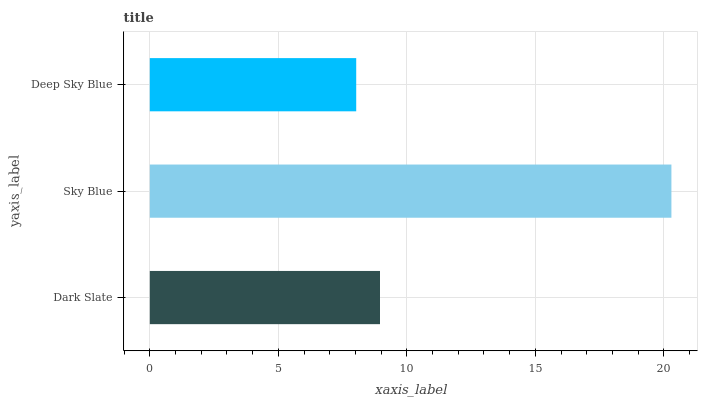Is Deep Sky Blue the minimum?
Answer yes or no. Yes. Is Sky Blue the maximum?
Answer yes or no. Yes. Is Sky Blue the minimum?
Answer yes or no. No. Is Deep Sky Blue the maximum?
Answer yes or no. No. Is Sky Blue greater than Deep Sky Blue?
Answer yes or no. Yes. Is Deep Sky Blue less than Sky Blue?
Answer yes or no. Yes. Is Deep Sky Blue greater than Sky Blue?
Answer yes or no. No. Is Sky Blue less than Deep Sky Blue?
Answer yes or no. No. Is Dark Slate the high median?
Answer yes or no. Yes. Is Dark Slate the low median?
Answer yes or no. Yes. Is Sky Blue the high median?
Answer yes or no. No. Is Sky Blue the low median?
Answer yes or no. No. 